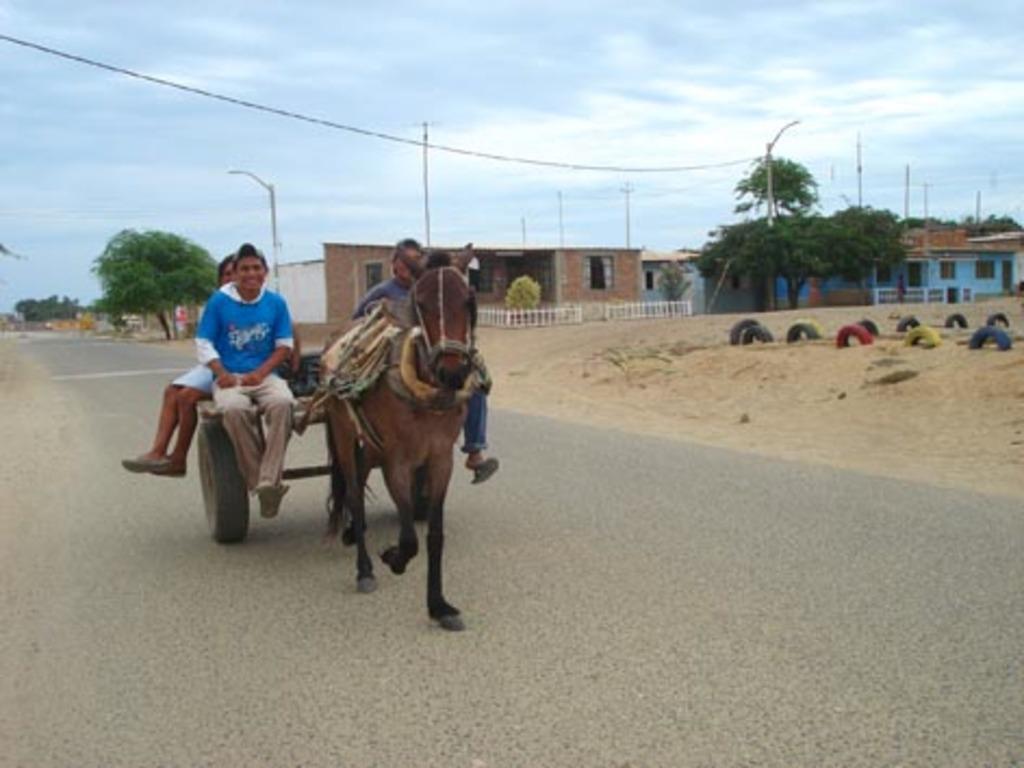Describe this image in one or two sentences. In the center of the image we can see a horse cart and there are people sitting on the horse cart. In the background there are buildings, trees, poles and wires. On the right there are tires. In the background there is sky. 